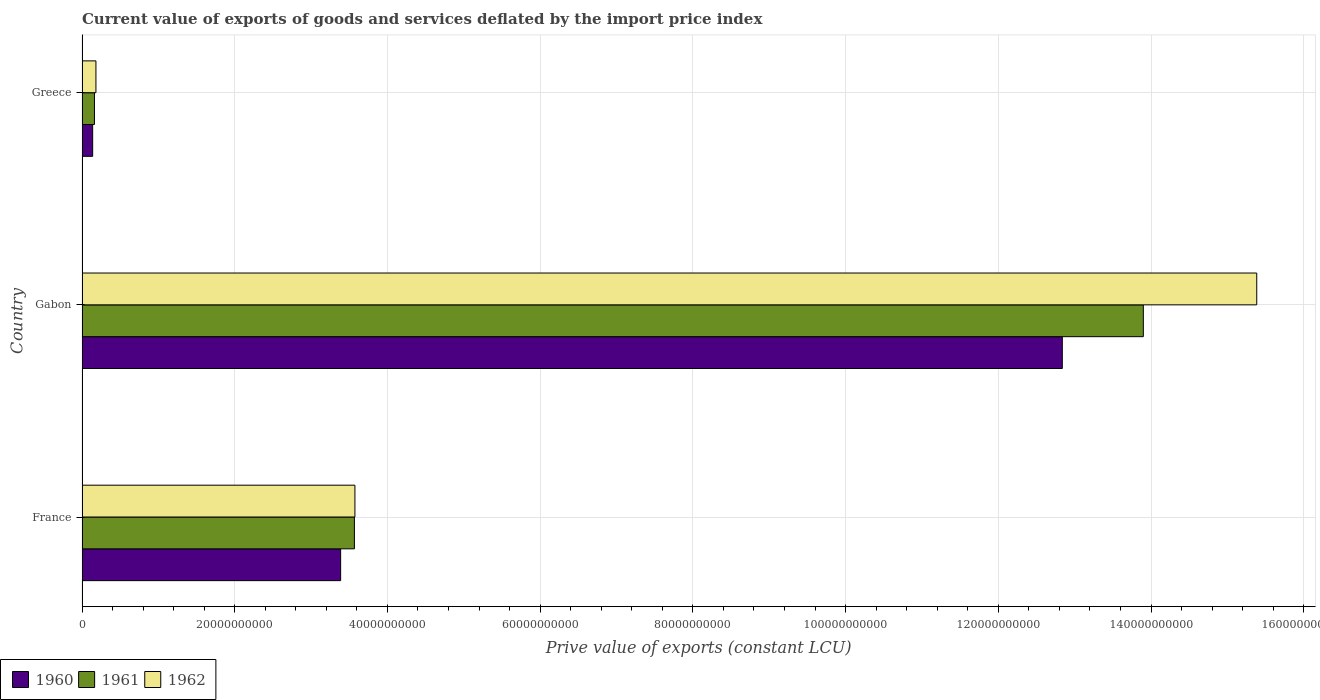How many different coloured bars are there?
Offer a terse response. 3. How many groups of bars are there?
Offer a very short reply. 3. Are the number of bars on each tick of the Y-axis equal?
Offer a very short reply. Yes. How many bars are there on the 3rd tick from the top?
Offer a very short reply. 3. What is the label of the 2nd group of bars from the top?
Your answer should be compact. Gabon. What is the prive value of exports in 1962 in France?
Your response must be concise. 3.57e+1. Across all countries, what is the maximum prive value of exports in 1961?
Provide a short and direct response. 1.39e+11. Across all countries, what is the minimum prive value of exports in 1960?
Your answer should be compact. 1.40e+09. In which country was the prive value of exports in 1961 maximum?
Offer a very short reply. Gabon. What is the total prive value of exports in 1960 in the graph?
Provide a succinct answer. 1.64e+11. What is the difference between the prive value of exports in 1962 in France and that in Greece?
Keep it short and to the point. 3.39e+1. What is the difference between the prive value of exports in 1962 in Greece and the prive value of exports in 1960 in Gabon?
Provide a short and direct response. -1.27e+11. What is the average prive value of exports in 1962 per country?
Keep it short and to the point. 6.38e+1. What is the difference between the prive value of exports in 1961 and prive value of exports in 1962 in Gabon?
Provide a succinct answer. -1.49e+1. What is the ratio of the prive value of exports in 1962 in France to that in Gabon?
Give a very brief answer. 0.23. What is the difference between the highest and the second highest prive value of exports in 1960?
Keep it short and to the point. 9.45e+1. What is the difference between the highest and the lowest prive value of exports in 1960?
Ensure brevity in your answer.  1.27e+11. In how many countries, is the prive value of exports in 1962 greater than the average prive value of exports in 1962 taken over all countries?
Offer a very short reply. 1. Is the sum of the prive value of exports in 1962 in France and Greece greater than the maximum prive value of exports in 1961 across all countries?
Ensure brevity in your answer.  No. What does the 3rd bar from the bottom in Gabon represents?
Offer a terse response. 1962. Does the graph contain grids?
Offer a very short reply. Yes. Where does the legend appear in the graph?
Keep it short and to the point. Bottom left. How many legend labels are there?
Offer a terse response. 3. How are the legend labels stacked?
Offer a terse response. Horizontal. What is the title of the graph?
Provide a succinct answer. Current value of exports of goods and services deflated by the import price index. What is the label or title of the X-axis?
Offer a very short reply. Prive value of exports (constant LCU). What is the label or title of the Y-axis?
Offer a terse response. Country. What is the Prive value of exports (constant LCU) of 1960 in France?
Make the answer very short. 3.39e+1. What is the Prive value of exports (constant LCU) of 1961 in France?
Your answer should be very brief. 3.57e+1. What is the Prive value of exports (constant LCU) in 1962 in France?
Offer a very short reply. 3.57e+1. What is the Prive value of exports (constant LCU) of 1960 in Gabon?
Provide a short and direct response. 1.28e+11. What is the Prive value of exports (constant LCU) of 1961 in Gabon?
Ensure brevity in your answer.  1.39e+11. What is the Prive value of exports (constant LCU) in 1962 in Gabon?
Provide a short and direct response. 1.54e+11. What is the Prive value of exports (constant LCU) of 1960 in Greece?
Offer a very short reply. 1.40e+09. What is the Prive value of exports (constant LCU) of 1961 in Greece?
Ensure brevity in your answer.  1.63e+09. What is the Prive value of exports (constant LCU) of 1962 in Greece?
Provide a succinct answer. 1.83e+09. Across all countries, what is the maximum Prive value of exports (constant LCU) of 1960?
Offer a very short reply. 1.28e+11. Across all countries, what is the maximum Prive value of exports (constant LCU) in 1961?
Ensure brevity in your answer.  1.39e+11. Across all countries, what is the maximum Prive value of exports (constant LCU) of 1962?
Your answer should be very brief. 1.54e+11. Across all countries, what is the minimum Prive value of exports (constant LCU) in 1960?
Provide a succinct answer. 1.40e+09. Across all countries, what is the minimum Prive value of exports (constant LCU) in 1961?
Offer a very short reply. 1.63e+09. Across all countries, what is the minimum Prive value of exports (constant LCU) of 1962?
Provide a succinct answer. 1.83e+09. What is the total Prive value of exports (constant LCU) in 1960 in the graph?
Offer a very short reply. 1.64e+11. What is the total Prive value of exports (constant LCU) of 1961 in the graph?
Your response must be concise. 1.76e+11. What is the total Prive value of exports (constant LCU) of 1962 in the graph?
Provide a succinct answer. 1.91e+11. What is the difference between the Prive value of exports (constant LCU) in 1960 in France and that in Gabon?
Offer a very short reply. -9.45e+1. What is the difference between the Prive value of exports (constant LCU) of 1961 in France and that in Gabon?
Your answer should be very brief. -1.03e+11. What is the difference between the Prive value of exports (constant LCU) in 1962 in France and that in Gabon?
Provide a succinct answer. -1.18e+11. What is the difference between the Prive value of exports (constant LCU) in 1960 in France and that in Greece?
Provide a succinct answer. 3.25e+1. What is the difference between the Prive value of exports (constant LCU) in 1961 in France and that in Greece?
Offer a terse response. 3.40e+1. What is the difference between the Prive value of exports (constant LCU) of 1962 in France and that in Greece?
Provide a short and direct response. 3.39e+1. What is the difference between the Prive value of exports (constant LCU) of 1960 in Gabon and that in Greece?
Offer a very short reply. 1.27e+11. What is the difference between the Prive value of exports (constant LCU) in 1961 in Gabon and that in Greece?
Keep it short and to the point. 1.37e+11. What is the difference between the Prive value of exports (constant LCU) of 1962 in Gabon and that in Greece?
Keep it short and to the point. 1.52e+11. What is the difference between the Prive value of exports (constant LCU) of 1960 in France and the Prive value of exports (constant LCU) of 1961 in Gabon?
Offer a very short reply. -1.05e+11. What is the difference between the Prive value of exports (constant LCU) of 1960 in France and the Prive value of exports (constant LCU) of 1962 in Gabon?
Offer a very short reply. -1.20e+11. What is the difference between the Prive value of exports (constant LCU) in 1961 in France and the Prive value of exports (constant LCU) in 1962 in Gabon?
Give a very brief answer. -1.18e+11. What is the difference between the Prive value of exports (constant LCU) in 1960 in France and the Prive value of exports (constant LCU) in 1961 in Greece?
Make the answer very short. 3.22e+1. What is the difference between the Prive value of exports (constant LCU) of 1960 in France and the Prive value of exports (constant LCU) of 1962 in Greece?
Give a very brief answer. 3.20e+1. What is the difference between the Prive value of exports (constant LCU) in 1961 in France and the Prive value of exports (constant LCU) in 1962 in Greece?
Your answer should be compact. 3.38e+1. What is the difference between the Prive value of exports (constant LCU) in 1960 in Gabon and the Prive value of exports (constant LCU) in 1961 in Greece?
Offer a terse response. 1.27e+11. What is the difference between the Prive value of exports (constant LCU) in 1960 in Gabon and the Prive value of exports (constant LCU) in 1962 in Greece?
Keep it short and to the point. 1.27e+11. What is the difference between the Prive value of exports (constant LCU) of 1961 in Gabon and the Prive value of exports (constant LCU) of 1962 in Greece?
Your answer should be very brief. 1.37e+11. What is the average Prive value of exports (constant LCU) in 1960 per country?
Make the answer very short. 5.45e+1. What is the average Prive value of exports (constant LCU) of 1961 per country?
Keep it short and to the point. 5.88e+1. What is the average Prive value of exports (constant LCU) of 1962 per country?
Your answer should be very brief. 6.38e+1. What is the difference between the Prive value of exports (constant LCU) in 1960 and Prive value of exports (constant LCU) in 1961 in France?
Your answer should be compact. -1.80e+09. What is the difference between the Prive value of exports (constant LCU) of 1960 and Prive value of exports (constant LCU) of 1962 in France?
Make the answer very short. -1.87e+09. What is the difference between the Prive value of exports (constant LCU) in 1961 and Prive value of exports (constant LCU) in 1962 in France?
Your answer should be very brief. -6.74e+07. What is the difference between the Prive value of exports (constant LCU) in 1960 and Prive value of exports (constant LCU) in 1961 in Gabon?
Give a very brief answer. -1.06e+1. What is the difference between the Prive value of exports (constant LCU) of 1960 and Prive value of exports (constant LCU) of 1962 in Gabon?
Provide a short and direct response. -2.55e+1. What is the difference between the Prive value of exports (constant LCU) of 1961 and Prive value of exports (constant LCU) of 1962 in Gabon?
Provide a short and direct response. -1.49e+1. What is the difference between the Prive value of exports (constant LCU) of 1960 and Prive value of exports (constant LCU) of 1961 in Greece?
Your answer should be very brief. -2.34e+08. What is the difference between the Prive value of exports (constant LCU) of 1960 and Prive value of exports (constant LCU) of 1962 in Greece?
Provide a succinct answer. -4.29e+08. What is the difference between the Prive value of exports (constant LCU) of 1961 and Prive value of exports (constant LCU) of 1962 in Greece?
Your answer should be very brief. -1.95e+08. What is the ratio of the Prive value of exports (constant LCU) of 1960 in France to that in Gabon?
Keep it short and to the point. 0.26. What is the ratio of the Prive value of exports (constant LCU) of 1961 in France to that in Gabon?
Give a very brief answer. 0.26. What is the ratio of the Prive value of exports (constant LCU) of 1962 in France to that in Gabon?
Make the answer very short. 0.23. What is the ratio of the Prive value of exports (constant LCU) of 1960 in France to that in Greece?
Offer a very short reply. 24.25. What is the ratio of the Prive value of exports (constant LCU) of 1961 in France to that in Greece?
Provide a succinct answer. 21.88. What is the ratio of the Prive value of exports (constant LCU) in 1962 in France to that in Greece?
Your response must be concise. 19.57. What is the ratio of the Prive value of exports (constant LCU) of 1960 in Gabon to that in Greece?
Offer a terse response. 91.91. What is the ratio of the Prive value of exports (constant LCU) of 1961 in Gabon to that in Greece?
Your response must be concise. 85.24. What is the ratio of the Prive value of exports (constant LCU) of 1962 in Gabon to that in Greece?
Keep it short and to the point. 84.26. What is the difference between the highest and the second highest Prive value of exports (constant LCU) of 1960?
Your response must be concise. 9.45e+1. What is the difference between the highest and the second highest Prive value of exports (constant LCU) in 1961?
Ensure brevity in your answer.  1.03e+11. What is the difference between the highest and the second highest Prive value of exports (constant LCU) of 1962?
Your answer should be compact. 1.18e+11. What is the difference between the highest and the lowest Prive value of exports (constant LCU) in 1960?
Your answer should be compact. 1.27e+11. What is the difference between the highest and the lowest Prive value of exports (constant LCU) of 1961?
Give a very brief answer. 1.37e+11. What is the difference between the highest and the lowest Prive value of exports (constant LCU) in 1962?
Offer a very short reply. 1.52e+11. 